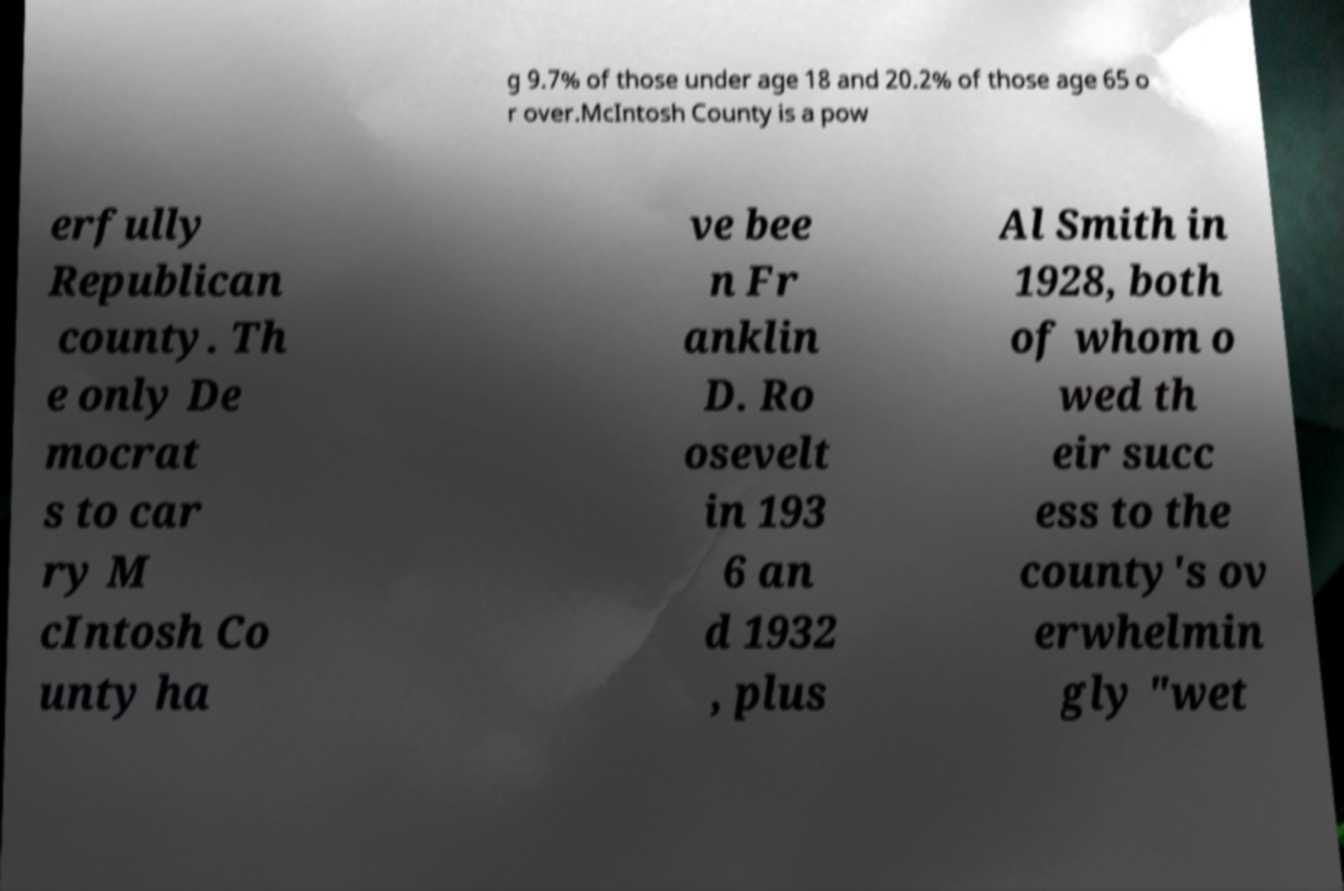Please identify and transcribe the text found in this image. g 9.7% of those under age 18 and 20.2% of those age 65 o r over.McIntosh County is a pow erfully Republican county. Th e only De mocrat s to car ry M cIntosh Co unty ha ve bee n Fr anklin D. Ro osevelt in 193 6 an d 1932 , plus Al Smith in 1928, both of whom o wed th eir succ ess to the county's ov erwhelmin gly "wet 